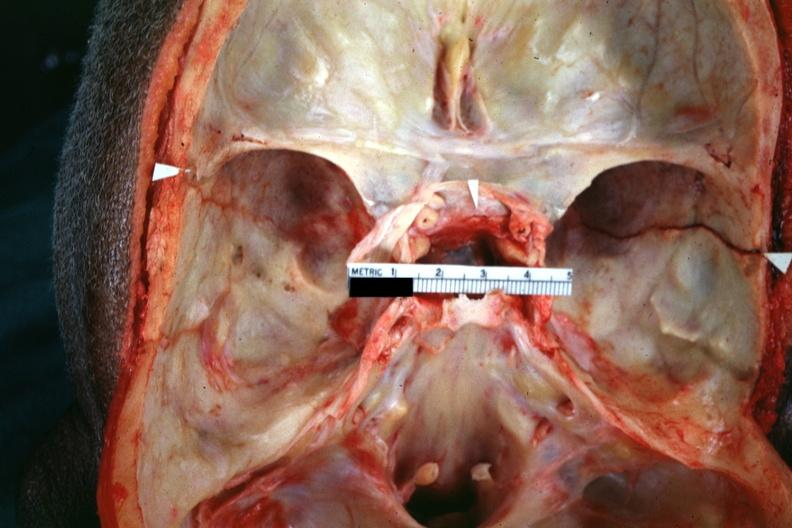what is close-up view shown?
Answer the question using a single word or phrase. View shown fracture line 